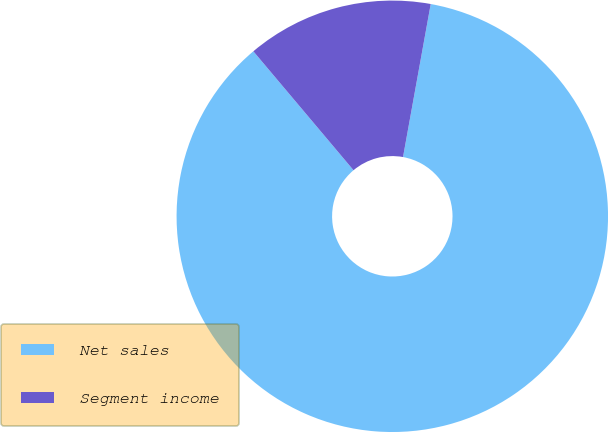Convert chart. <chart><loc_0><loc_0><loc_500><loc_500><pie_chart><fcel>Net sales<fcel>Segment income<nl><fcel>86.01%<fcel>13.99%<nl></chart> 